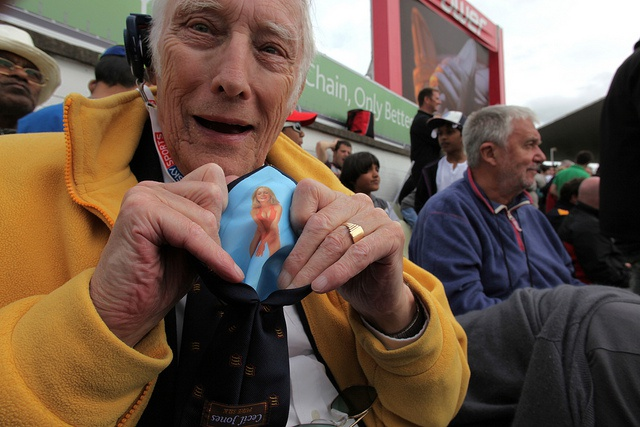Describe the objects in this image and their specific colors. I can see people in black, olive, maroon, and brown tones, people in black, navy, gray, and maroon tones, tie in black, maroon, gray, and navy tones, tie in black, gray, lightblue, and brown tones, and people in black, maroon, and gray tones in this image. 